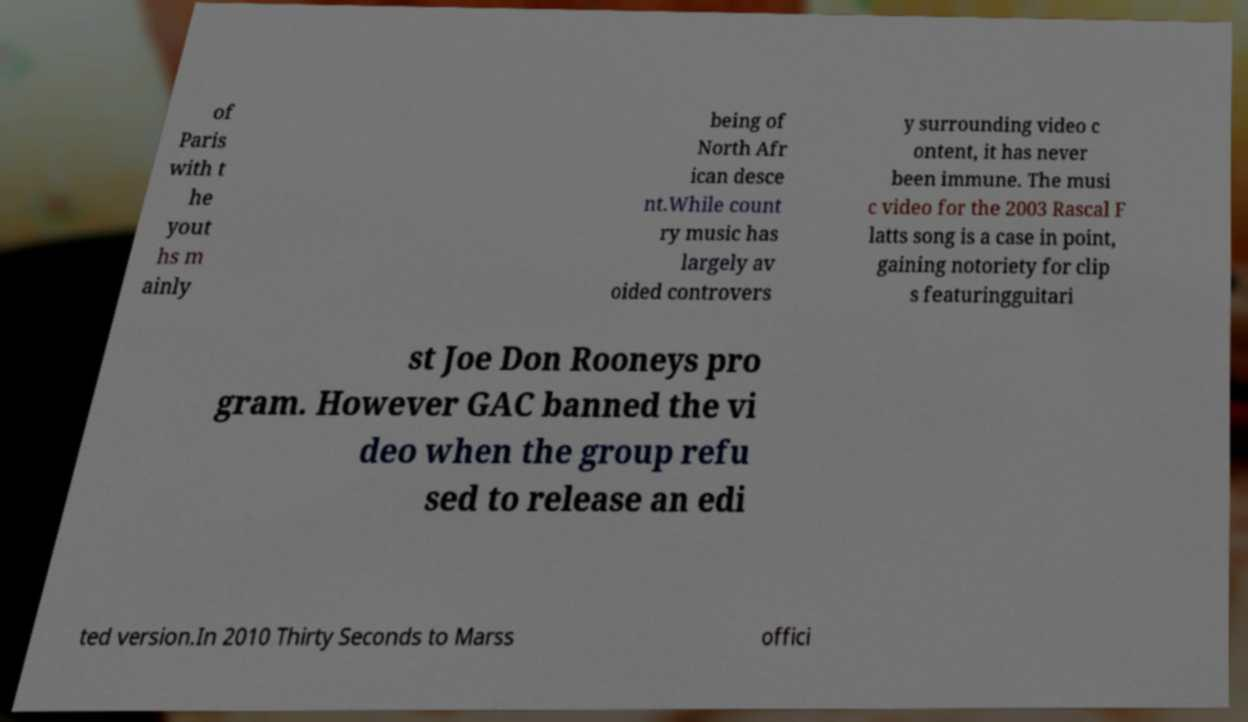I need the written content from this picture converted into text. Can you do that? of Paris with t he yout hs m ainly being of North Afr ican desce nt.While count ry music has largely av oided controvers y surrounding video c ontent, it has never been immune. The musi c video for the 2003 Rascal F latts song is a case in point, gaining notoriety for clip s featuringguitari st Joe Don Rooneys pro gram. However GAC banned the vi deo when the group refu sed to release an edi ted version.In 2010 Thirty Seconds to Marss offici 